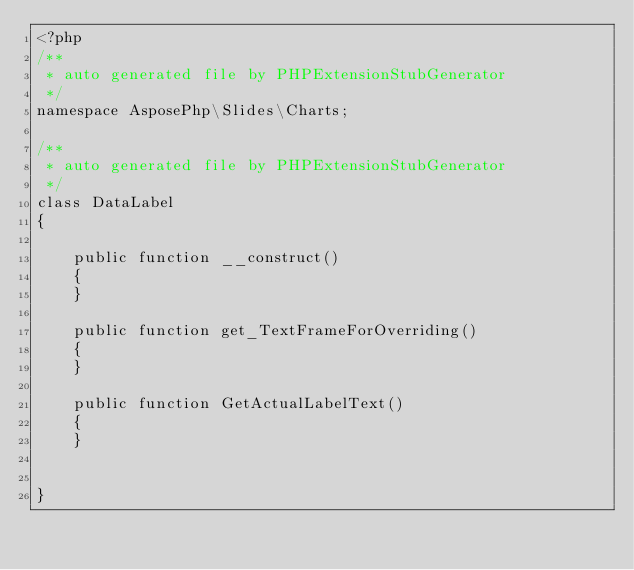<code> <loc_0><loc_0><loc_500><loc_500><_PHP_><?php
/**
 * auto generated file by PHPExtensionStubGenerator
 */
namespace AsposePhp\Slides\Charts;

/**
 * auto generated file by PHPExtensionStubGenerator
 */
class DataLabel
{

    public function __construct()
    {
    }

    public function get_TextFrameForOverriding()
    {
    }

    public function GetActualLabelText()
    {
    }


}
</code> 